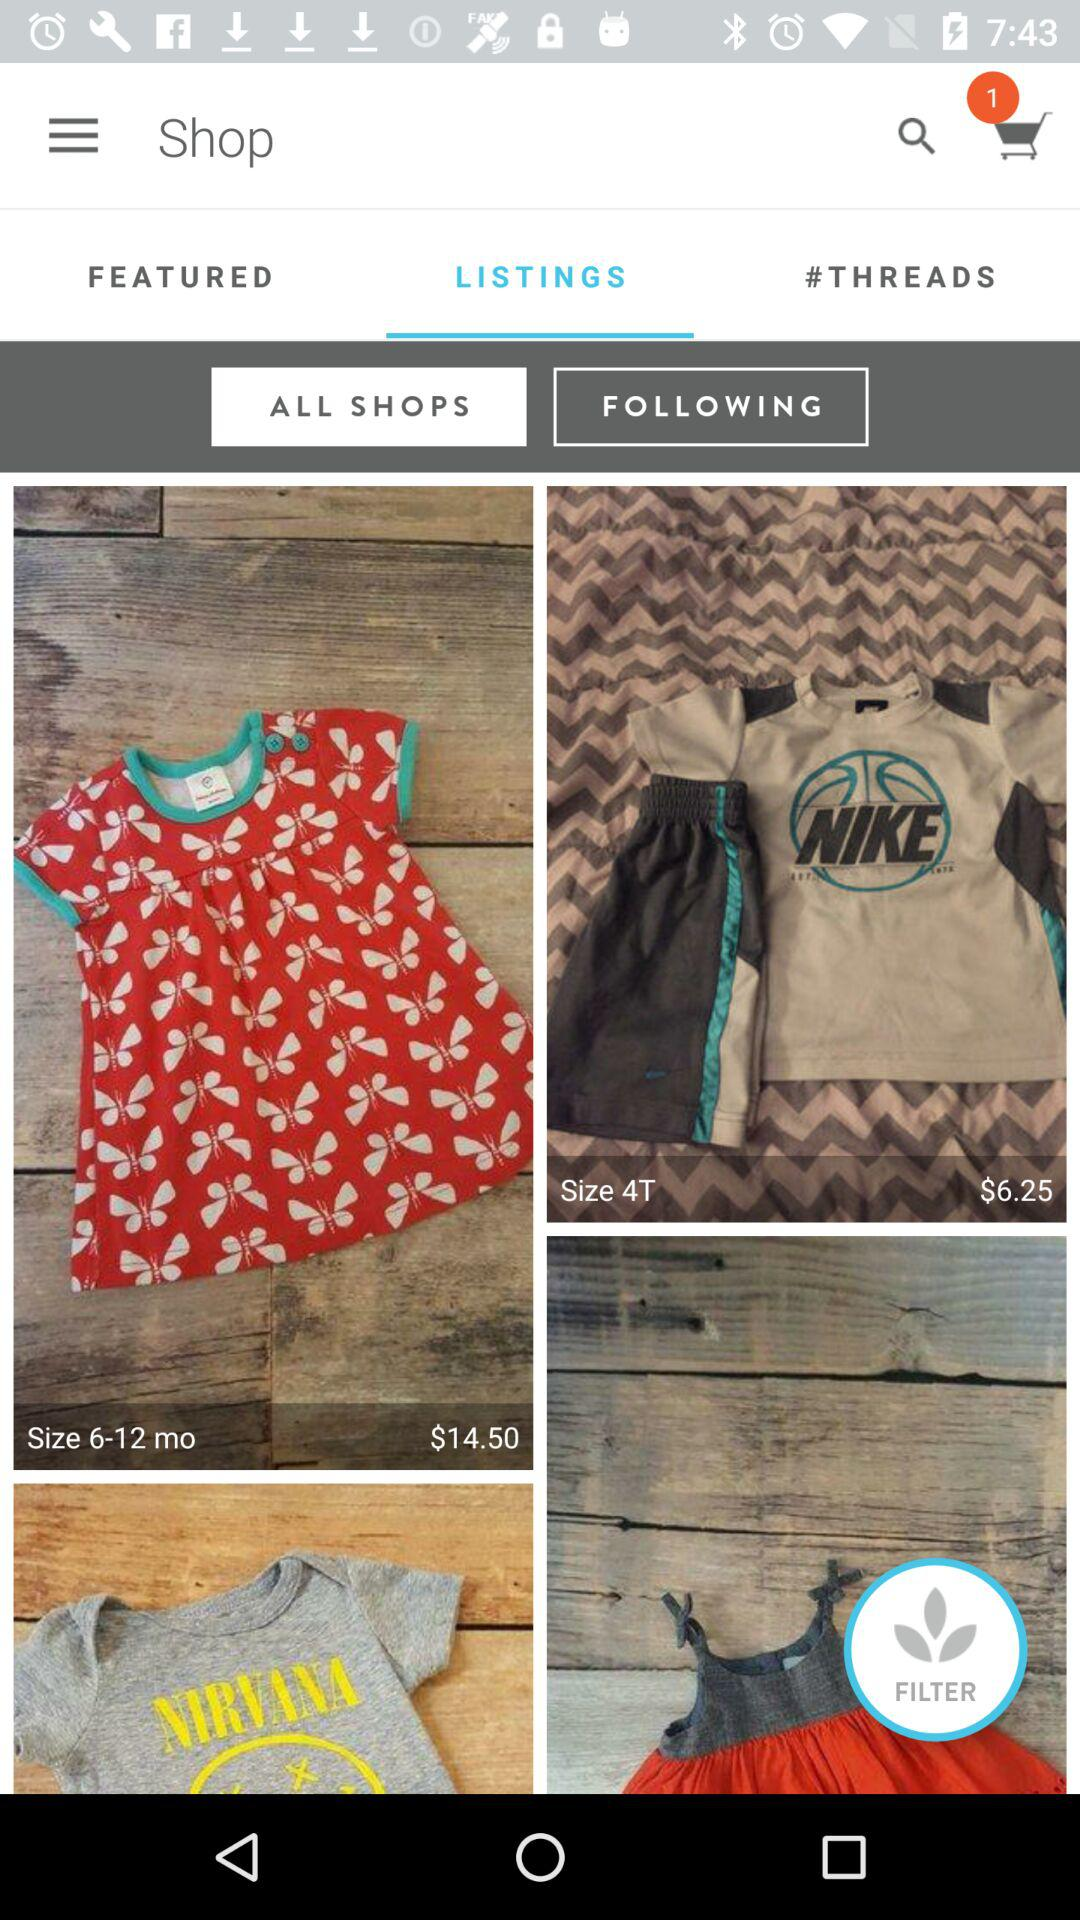What's the price of the apparel in "Size 4T"? The price of the apparel in "Size 4T" is $6.25. 